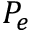Convert formula to latex. <formula><loc_0><loc_0><loc_500><loc_500>P _ { e }</formula> 